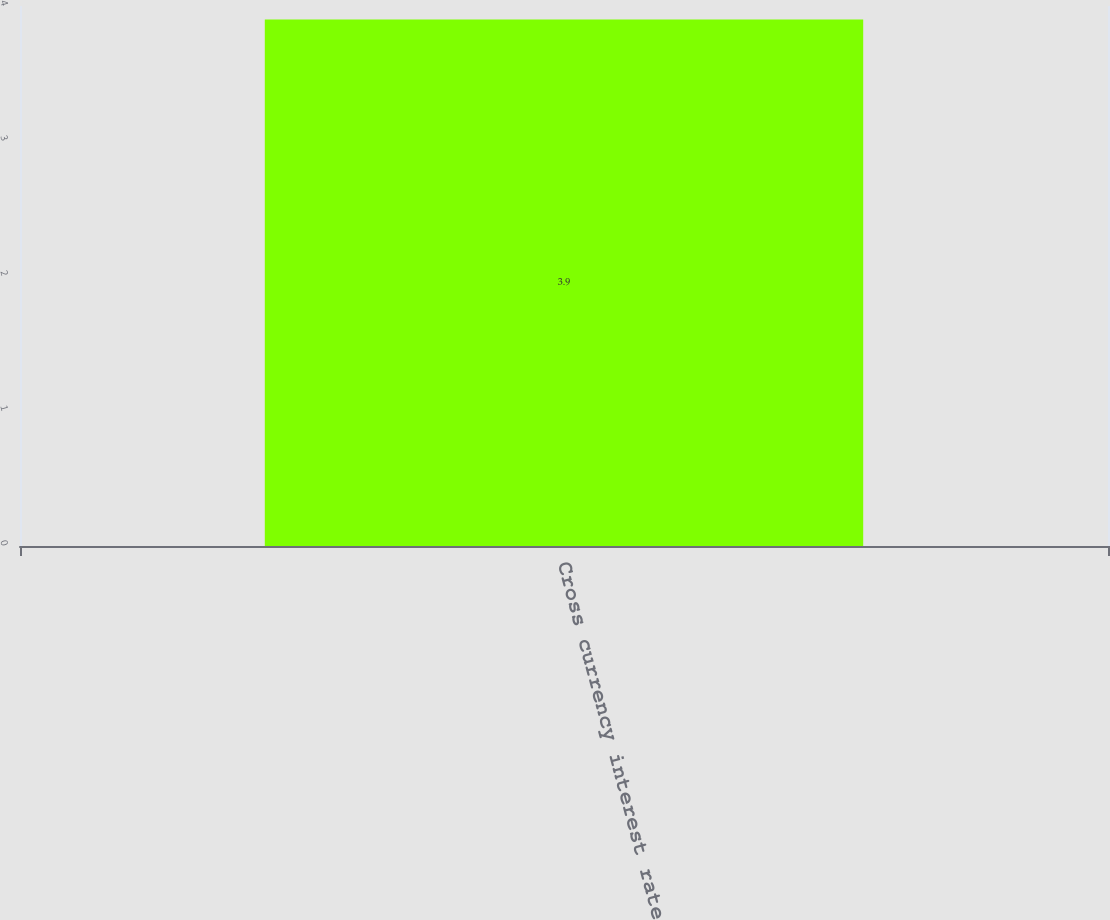Convert chart. <chart><loc_0><loc_0><loc_500><loc_500><bar_chart><fcel>Cross currency interest rate<nl><fcel>3.9<nl></chart> 